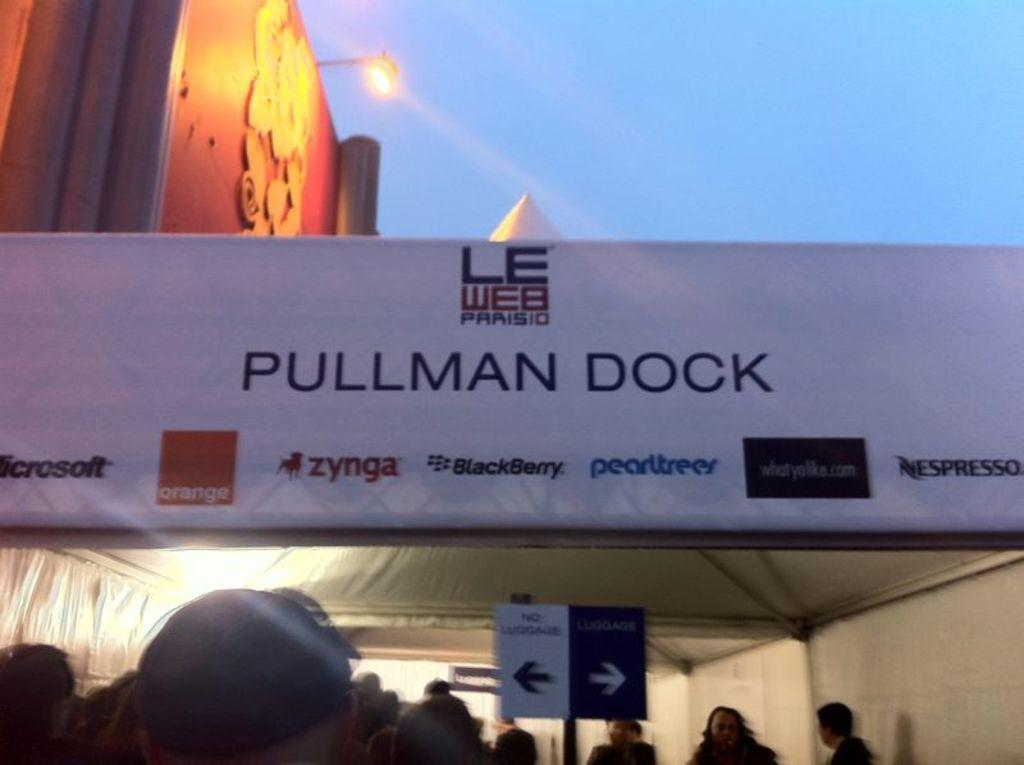<image>
Offer a succinct explanation of the picture presented. People walk through a tunnel at Pullman Dock following signs that point left for no luggage and right for luggage. 